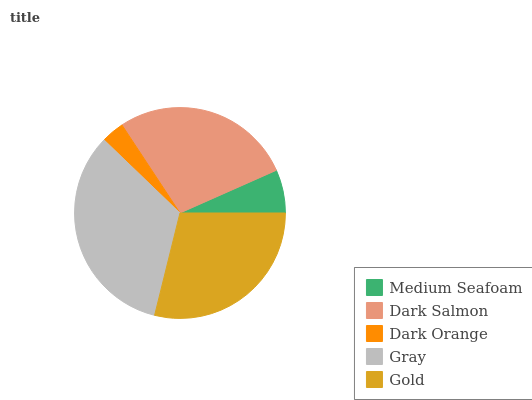Is Dark Orange the minimum?
Answer yes or no. Yes. Is Gray the maximum?
Answer yes or no. Yes. Is Dark Salmon the minimum?
Answer yes or no. No. Is Dark Salmon the maximum?
Answer yes or no. No. Is Dark Salmon greater than Medium Seafoam?
Answer yes or no. Yes. Is Medium Seafoam less than Dark Salmon?
Answer yes or no. Yes. Is Medium Seafoam greater than Dark Salmon?
Answer yes or no. No. Is Dark Salmon less than Medium Seafoam?
Answer yes or no. No. Is Dark Salmon the high median?
Answer yes or no. Yes. Is Dark Salmon the low median?
Answer yes or no. Yes. Is Gray the high median?
Answer yes or no. No. Is Medium Seafoam the low median?
Answer yes or no. No. 